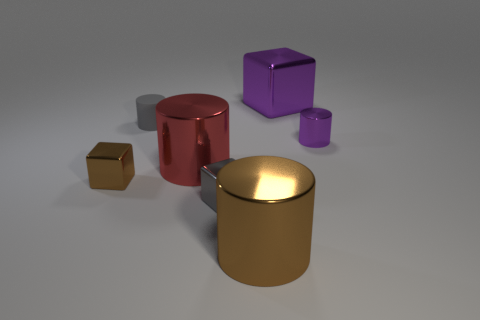Are there any large purple metal objects of the same shape as the red shiny thing?
Provide a succinct answer. No. Are there any other things that have the same shape as the matte thing?
Offer a very short reply. Yes. The tiny cylinder that is behind the metal object that is to the right of the purple shiny cube behind the tiny purple thing is made of what material?
Your answer should be very brief. Rubber. Are there any red matte things that have the same size as the brown metal block?
Your answer should be compact. No. There is a cube behind the small cylinder that is to the right of the purple metal block; what is its color?
Provide a short and direct response. Purple. How many metal cylinders are there?
Your answer should be compact. 3. Is the color of the small metal cylinder the same as the big metal cube?
Give a very brief answer. Yes. Is the number of red cylinders on the right side of the purple cylinder less than the number of large purple blocks in front of the rubber cylinder?
Your response must be concise. No. What color is the small shiny cylinder?
Give a very brief answer. Purple. How many tiny shiny things are the same color as the big metal cube?
Offer a terse response. 1. 